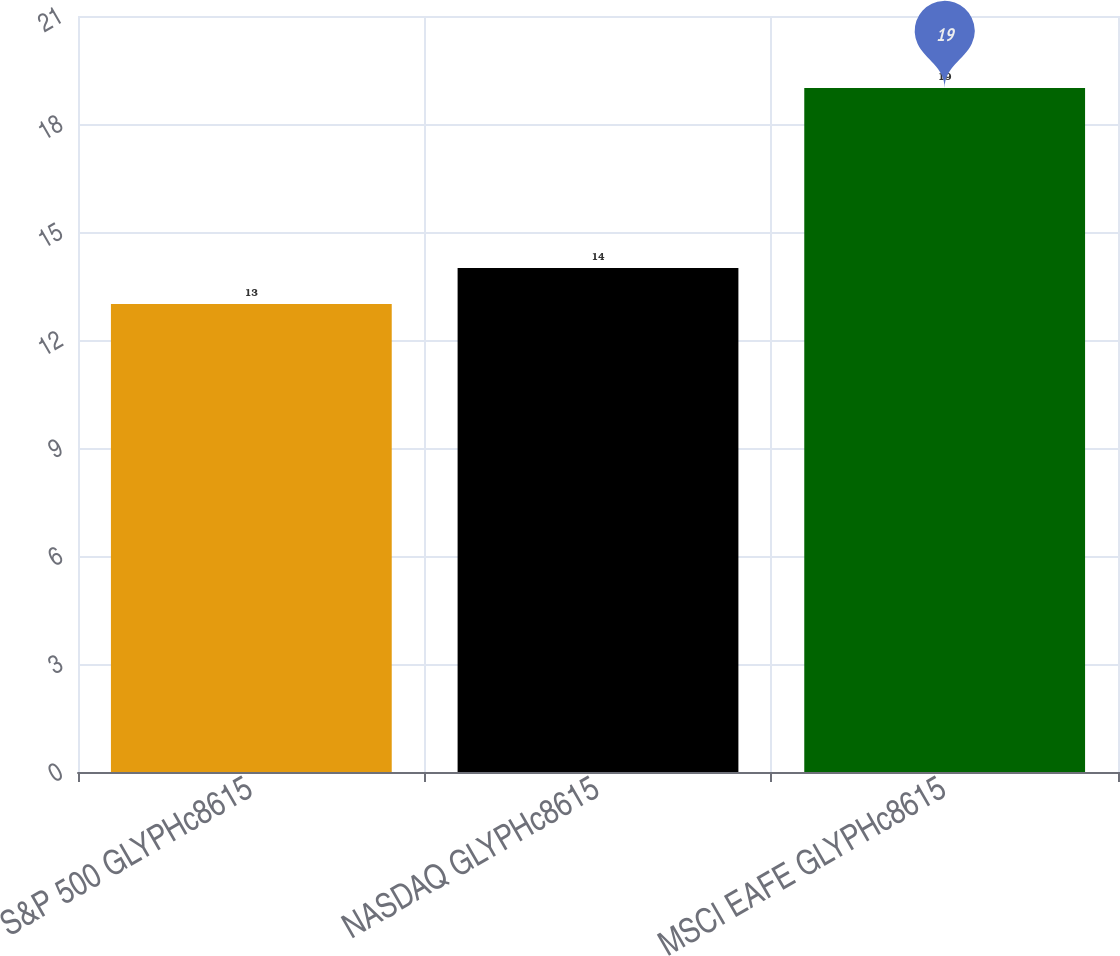Convert chart. <chart><loc_0><loc_0><loc_500><loc_500><bar_chart><fcel>S&P 500 GLYPHc8615<fcel>NASDAQ GLYPHc8615<fcel>MSCI EAFE GLYPHc8615<nl><fcel>13<fcel>14<fcel>19<nl></chart> 